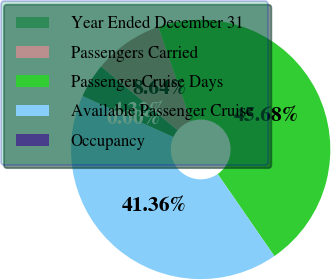Convert chart. <chart><loc_0><loc_0><loc_500><loc_500><pie_chart><fcel>Year Ended December 31<fcel>Passengers Carried<fcel>Passenger Cruise Days<fcel>Available Passenger Cruise<fcel>Occupancy<nl><fcel>4.32%<fcel>8.64%<fcel>45.68%<fcel>41.36%<fcel>0.0%<nl></chart> 